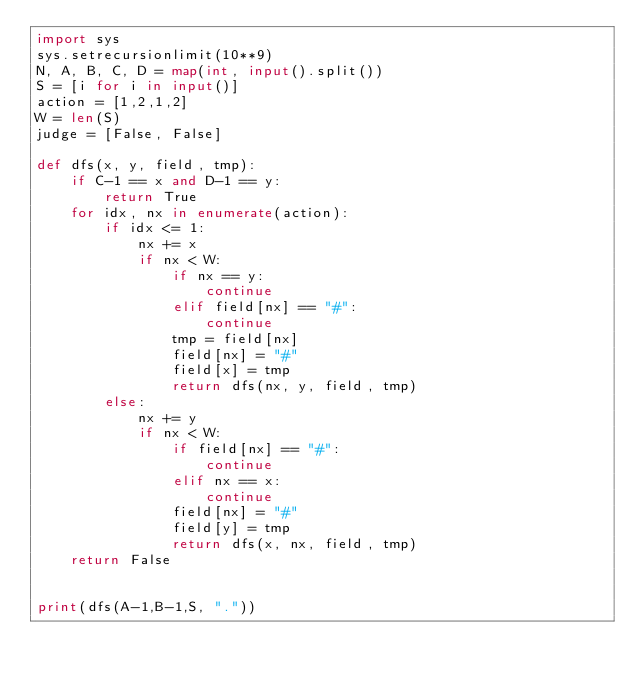Convert code to text. <code><loc_0><loc_0><loc_500><loc_500><_Python_>import sys
sys.setrecursionlimit(10**9)
N, A, B, C, D = map(int, input().split())
S = [i for i in input()]
action = [1,2,1,2]
W = len(S)
judge = [False, False]

def dfs(x, y, field, tmp):
    if C-1 == x and D-1 == y:
        return True
    for idx, nx in enumerate(action):
        if idx <= 1:
            nx += x
            if nx < W:
                if nx == y:
                    continue
                elif field[nx] == "#":
                    continue
                tmp = field[nx]
                field[nx] = "#"
                field[x] = tmp
                return dfs(nx, y, field, tmp)
        else:
            nx += y
            if nx < W:
                if field[nx] == "#":
                    continue
                elif nx == x:
                    continue
                field[nx] = "#"
                field[y] = tmp
                return dfs(x, nx, field, tmp)
    return False


print(dfs(A-1,B-1,S, "."))
</code> 